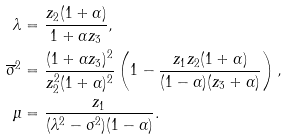Convert formula to latex. <formula><loc_0><loc_0><loc_500><loc_500>\lambda & = \frac { z _ { 2 } ( 1 + \alpha ) } { 1 + \alpha z _ { 3 } } , \\ \overline { \sigma } ^ { 2 } & = \frac { ( 1 + \alpha z _ { 3 } ) ^ { 2 } } { z _ { 2 } ^ { 2 } ( 1 + \alpha ) ^ { 2 } } \left ( 1 - \frac { z _ { 1 } z _ { 2 } ( 1 + \alpha ) } { ( 1 - \alpha ) ( z _ { 3 } + \alpha ) } \right ) , \\ \mu & = \frac { z _ { 1 } } { ( \lambda ^ { 2 } - \sigma ^ { 2 } ) ( 1 - \alpha ) } .</formula> 